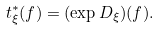<formula> <loc_0><loc_0><loc_500><loc_500>t _ { \xi } ^ { * } ( f ) = ( \exp { D _ { \xi } } ) ( f ) .</formula> 